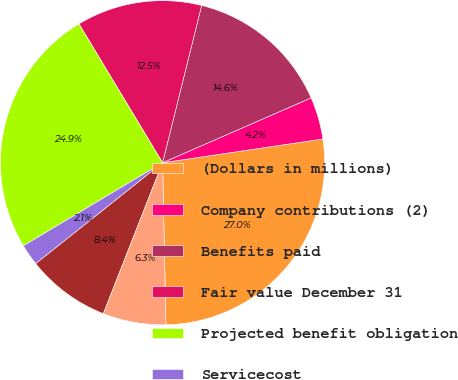Convert chart to OTSL. <chart><loc_0><loc_0><loc_500><loc_500><pie_chart><fcel>(Dollars in millions)<fcel>Company contributions (2)<fcel>Benefits paid<fcel>Fair value December 31<fcel>Projected benefit obligation<fcel>Servicecost<fcel>Interestcost<fcel>Actuarialloss<nl><fcel>27.01%<fcel>4.21%<fcel>14.57%<fcel>12.5%<fcel>24.94%<fcel>2.13%<fcel>8.35%<fcel>6.28%<nl></chart> 